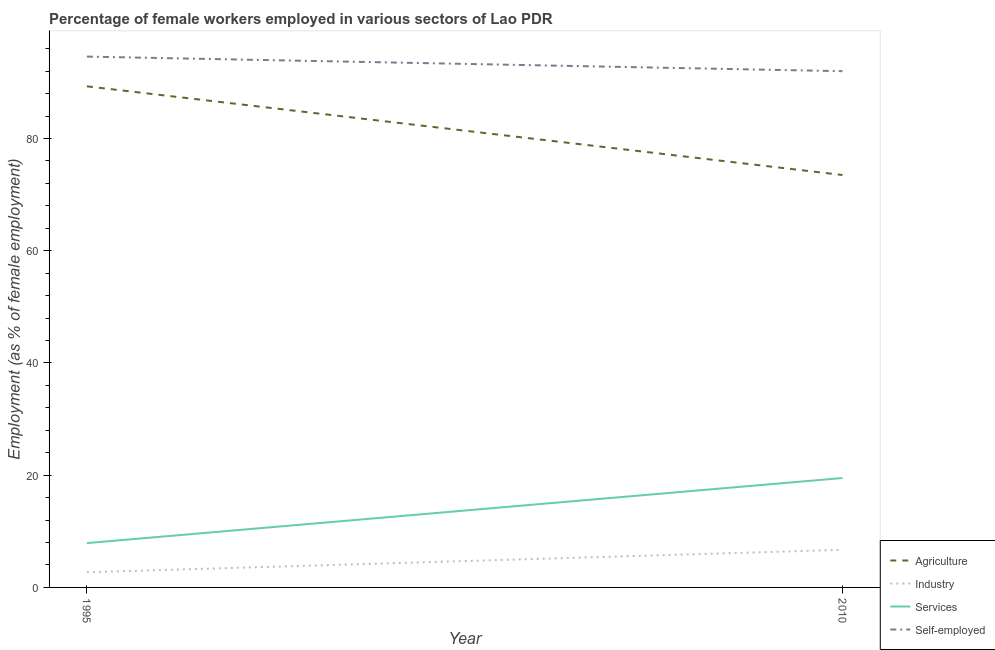How many different coloured lines are there?
Your response must be concise. 4. Does the line corresponding to percentage of female workers in agriculture intersect with the line corresponding to percentage of female workers in industry?
Your answer should be compact. No. What is the percentage of self employed female workers in 2010?
Offer a terse response. 92. Across all years, what is the maximum percentage of self employed female workers?
Offer a terse response. 94.6. Across all years, what is the minimum percentage of self employed female workers?
Provide a short and direct response. 92. In which year was the percentage of self employed female workers maximum?
Make the answer very short. 1995. In which year was the percentage of female workers in agriculture minimum?
Your answer should be very brief. 2010. What is the total percentage of self employed female workers in the graph?
Offer a terse response. 186.6. What is the difference between the percentage of female workers in industry in 1995 and that in 2010?
Your answer should be very brief. -4. What is the difference between the percentage of self employed female workers in 1995 and the percentage of female workers in services in 2010?
Provide a succinct answer. 75.1. What is the average percentage of female workers in agriculture per year?
Offer a terse response. 81.4. In the year 1995, what is the difference between the percentage of female workers in agriculture and percentage of female workers in services?
Your answer should be very brief. 81.4. What is the ratio of the percentage of female workers in services in 1995 to that in 2010?
Provide a succinct answer. 0.41. Is the percentage of self employed female workers in 1995 less than that in 2010?
Give a very brief answer. No. Is it the case that in every year, the sum of the percentage of female workers in agriculture and percentage of female workers in services is greater than the sum of percentage of self employed female workers and percentage of female workers in industry?
Provide a succinct answer. Yes. Does the percentage of female workers in industry monotonically increase over the years?
Keep it short and to the point. Yes. Is the percentage of female workers in industry strictly greater than the percentage of self employed female workers over the years?
Give a very brief answer. No. Is the percentage of female workers in agriculture strictly less than the percentage of female workers in industry over the years?
Your answer should be compact. No. How many lines are there?
Your answer should be compact. 4. How many years are there in the graph?
Ensure brevity in your answer.  2. What is the difference between two consecutive major ticks on the Y-axis?
Ensure brevity in your answer.  20. Does the graph contain grids?
Ensure brevity in your answer.  No. Where does the legend appear in the graph?
Your answer should be very brief. Bottom right. What is the title of the graph?
Provide a succinct answer. Percentage of female workers employed in various sectors of Lao PDR. What is the label or title of the Y-axis?
Your answer should be compact. Employment (as % of female employment). What is the Employment (as % of female employment) of Agriculture in 1995?
Ensure brevity in your answer.  89.3. What is the Employment (as % of female employment) of Industry in 1995?
Your answer should be compact. 2.7. What is the Employment (as % of female employment) in Services in 1995?
Provide a short and direct response. 7.9. What is the Employment (as % of female employment) of Self-employed in 1995?
Offer a terse response. 94.6. What is the Employment (as % of female employment) of Agriculture in 2010?
Provide a short and direct response. 73.5. What is the Employment (as % of female employment) in Industry in 2010?
Your answer should be very brief. 6.7. What is the Employment (as % of female employment) in Self-employed in 2010?
Make the answer very short. 92. Across all years, what is the maximum Employment (as % of female employment) in Agriculture?
Offer a very short reply. 89.3. Across all years, what is the maximum Employment (as % of female employment) in Industry?
Offer a very short reply. 6.7. Across all years, what is the maximum Employment (as % of female employment) in Self-employed?
Your response must be concise. 94.6. Across all years, what is the minimum Employment (as % of female employment) of Agriculture?
Keep it short and to the point. 73.5. Across all years, what is the minimum Employment (as % of female employment) of Industry?
Your answer should be very brief. 2.7. Across all years, what is the minimum Employment (as % of female employment) in Services?
Provide a short and direct response. 7.9. Across all years, what is the minimum Employment (as % of female employment) of Self-employed?
Make the answer very short. 92. What is the total Employment (as % of female employment) of Agriculture in the graph?
Keep it short and to the point. 162.8. What is the total Employment (as % of female employment) in Industry in the graph?
Your answer should be very brief. 9.4. What is the total Employment (as % of female employment) in Services in the graph?
Your answer should be very brief. 27.4. What is the total Employment (as % of female employment) of Self-employed in the graph?
Keep it short and to the point. 186.6. What is the difference between the Employment (as % of female employment) in Agriculture in 1995 and that in 2010?
Offer a terse response. 15.8. What is the difference between the Employment (as % of female employment) in Industry in 1995 and that in 2010?
Your answer should be very brief. -4. What is the difference between the Employment (as % of female employment) in Services in 1995 and that in 2010?
Offer a terse response. -11.6. What is the difference between the Employment (as % of female employment) of Agriculture in 1995 and the Employment (as % of female employment) of Industry in 2010?
Your answer should be compact. 82.6. What is the difference between the Employment (as % of female employment) of Agriculture in 1995 and the Employment (as % of female employment) of Services in 2010?
Give a very brief answer. 69.8. What is the difference between the Employment (as % of female employment) of Agriculture in 1995 and the Employment (as % of female employment) of Self-employed in 2010?
Make the answer very short. -2.7. What is the difference between the Employment (as % of female employment) in Industry in 1995 and the Employment (as % of female employment) in Services in 2010?
Offer a terse response. -16.8. What is the difference between the Employment (as % of female employment) of Industry in 1995 and the Employment (as % of female employment) of Self-employed in 2010?
Make the answer very short. -89.3. What is the difference between the Employment (as % of female employment) of Services in 1995 and the Employment (as % of female employment) of Self-employed in 2010?
Offer a very short reply. -84.1. What is the average Employment (as % of female employment) of Agriculture per year?
Offer a very short reply. 81.4. What is the average Employment (as % of female employment) of Industry per year?
Provide a short and direct response. 4.7. What is the average Employment (as % of female employment) of Self-employed per year?
Provide a short and direct response. 93.3. In the year 1995, what is the difference between the Employment (as % of female employment) in Agriculture and Employment (as % of female employment) in Industry?
Provide a succinct answer. 86.6. In the year 1995, what is the difference between the Employment (as % of female employment) in Agriculture and Employment (as % of female employment) in Services?
Offer a very short reply. 81.4. In the year 1995, what is the difference between the Employment (as % of female employment) of Agriculture and Employment (as % of female employment) of Self-employed?
Make the answer very short. -5.3. In the year 1995, what is the difference between the Employment (as % of female employment) of Industry and Employment (as % of female employment) of Services?
Your answer should be very brief. -5.2. In the year 1995, what is the difference between the Employment (as % of female employment) in Industry and Employment (as % of female employment) in Self-employed?
Your response must be concise. -91.9. In the year 1995, what is the difference between the Employment (as % of female employment) of Services and Employment (as % of female employment) of Self-employed?
Offer a terse response. -86.7. In the year 2010, what is the difference between the Employment (as % of female employment) in Agriculture and Employment (as % of female employment) in Industry?
Ensure brevity in your answer.  66.8. In the year 2010, what is the difference between the Employment (as % of female employment) in Agriculture and Employment (as % of female employment) in Services?
Your answer should be compact. 54. In the year 2010, what is the difference between the Employment (as % of female employment) of Agriculture and Employment (as % of female employment) of Self-employed?
Your response must be concise. -18.5. In the year 2010, what is the difference between the Employment (as % of female employment) in Industry and Employment (as % of female employment) in Services?
Provide a short and direct response. -12.8. In the year 2010, what is the difference between the Employment (as % of female employment) of Industry and Employment (as % of female employment) of Self-employed?
Give a very brief answer. -85.3. In the year 2010, what is the difference between the Employment (as % of female employment) in Services and Employment (as % of female employment) in Self-employed?
Provide a succinct answer. -72.5. What is the ratio of the Employment (as % of female employment) in Agriculture in 1995 to that in 2010?
Offer a terse response. 1.22. What is the ratio of the Employment (as % of female employment) of Industry in 1995 to that in 2010?
Your answer should be compact. 0.4. What is the ratio of the Employment (as % of female employment) in Services in 1995 to that in 2010?
Offer a very short reply. 0.41. What is the ratio of the Employment (as % of female employment) of Self-employed in 1995 to that in 2010?
Provide a short and direct response. 1.03. What is the difference between the highest and the second highest Employment (as % of female employment) in Services?
Your answer should be very brief. 11.6. What is the difference between the highest and the lowest Employment (as % of female employment) of Agriculture?
Give a very brief answer. 15.8. 